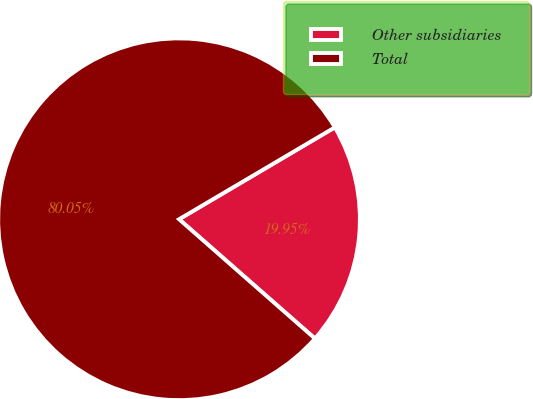<chart> <loc_0><loc_0><loc_500><loc_500><pie_chart><fcel>Other subsidiaries<fcel>Total<nl><fcel>19.95%<fcel>80.05%<nl></chart> 